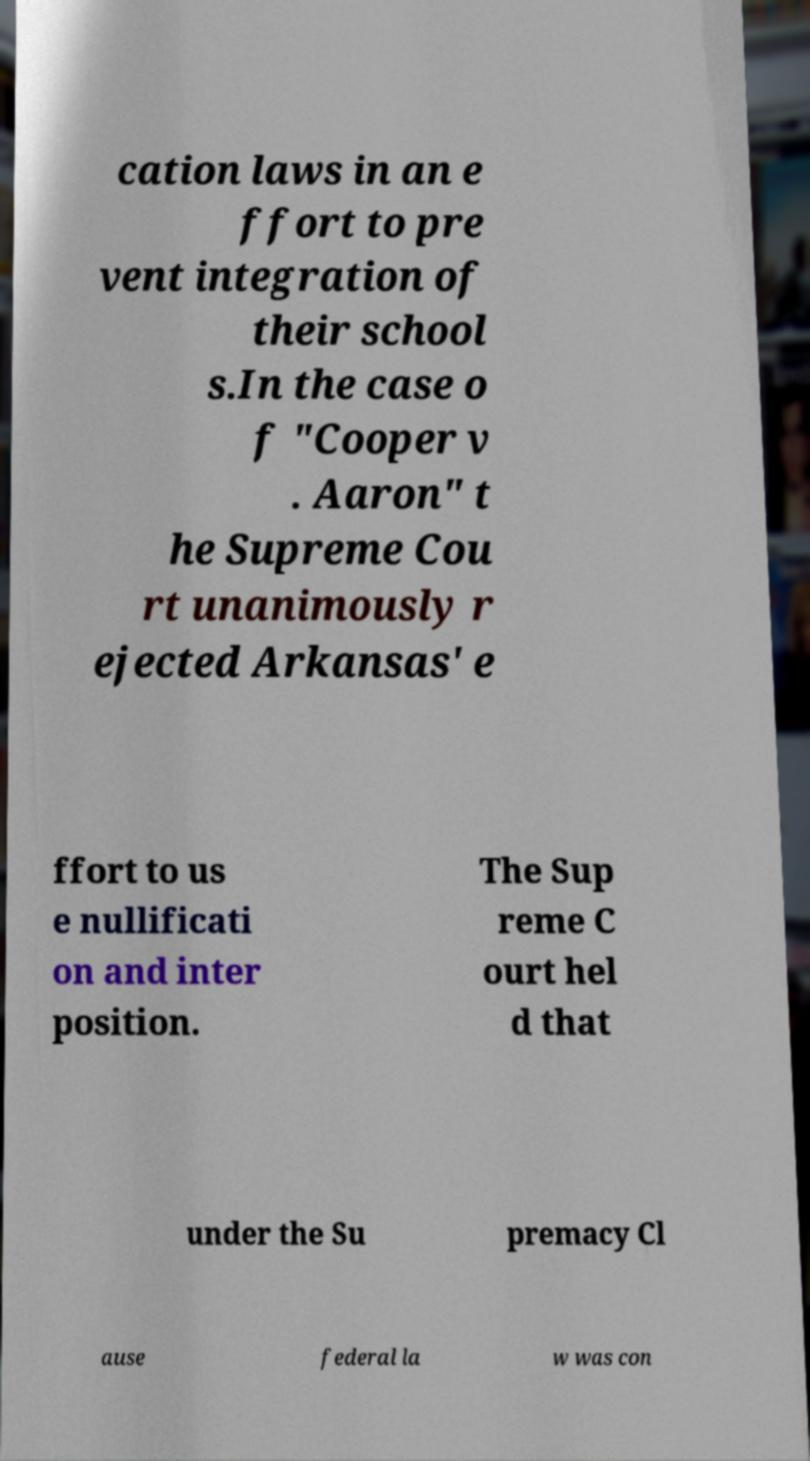What messages or text are displayed in this image? I need them in a readable, typed format. cation laws in an e ffort to pre vent integration of their school s.In the case o f "Cooper v . Aaron" t he Supreme Cou rt unanimously r ejected Arkansas' e ffort to us e nullificati on and inter position. The Sup reme C ourt hel d that under the Su premacy Cl ause federal la w was con 